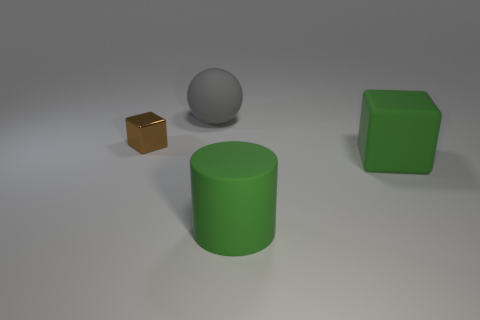Are there any other things that have the same material as the brown cube?
Your answer should be compact. No. Are there any other things that have the same size as the metallic object?
Your response must be concise. No. What number of other brown shiny objects have the same shape as the tiny brown thing?
Offer a very short reply. 0. There is a thing that is both behind the green block and to the right of the small brown thing; what color is it?
Your answer should be very brief. Gray. How many tiny cyan blocks are there?
Your answer should be compact. 0. Do the green block and the gray matte ball have the same size?
Make the answer very short. Yes. Is there another tiny cube of the same color as the rubber block?
Offer a terse response. No. There is a rubber object that is behind the brown metal thing; is it the same shape as the small thing?
Provide a short and direct response. No. How many brown things have the same size as the matte ball?
Offer a terse response. 0. There is a large rubber thing that is behind the small brown block; how many big objects are in front of it?
Your response must be concise. 2. 